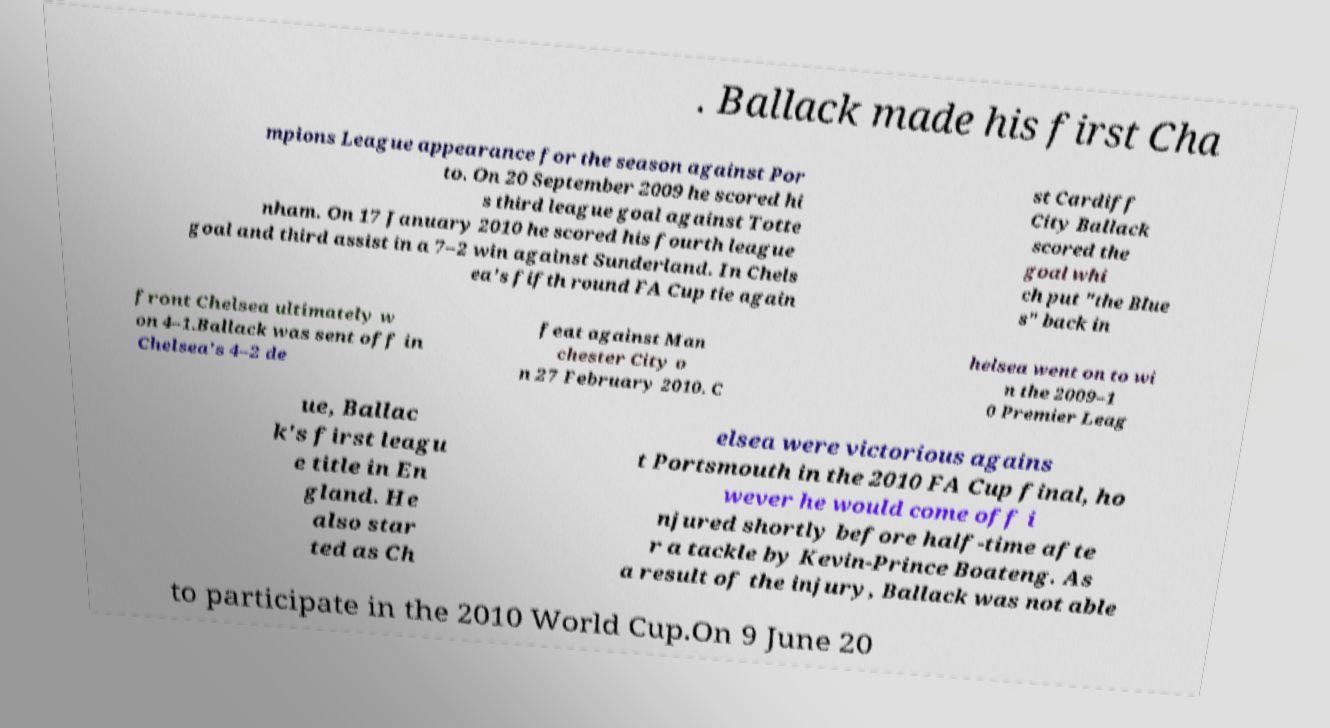Please identify and transcribe the text found in this image. . Ballack made his first Cha mpions League appearance for the season against Por to. On 20 September 2009 he scored hi s third league goal against Totte nham. On 17 January 2010 he scored his fourth league goal and third assist in a 7–2 win against Sunderland. In Chels ea's fifth round FA Cup tie again st Cardiff City Ballack scored the goal whi ch put "the Blue s" back in front Chelsea ultimately w on 4–1.Ballack was sent off in Chelsea's 4–2 de feat against Man chester City o n 27 February 2010. C helsea went on to wi n the 2009–1 0 Premier Leag ue, Ballac k's first leagu e title in En gland. He also star ted as Ch elsea were victorious agains t Portsmouth in the 2010 FA Cup final, ho wever he would come off i njured shortly before half-time afte r a tackle by Kevin-Prince Boateng. As a result of the injury, Ballack was not able to participate in the 2010 World Cup.On 9 June 20 